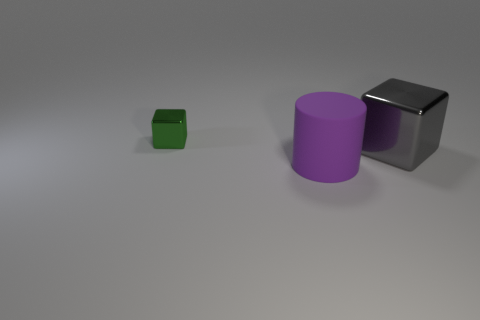There is a metallic object right of the shiny object behind the metal block in front of the tiny shiny cube; how big is it?
Keep it short and to the point. Large. There is a thing that is behind the big purple object and to the left of the big gray object; what is its shape?
Your response must be concise. Cube. Are there an equal number of gray cubes that are right of the purple cylinder and purple rubber things that are on the right side of the gray metallic block?
Ensure brevity in your answer.  No. Is there another cylinder that has the same material as the cylinder?
Give a very brief answer. No. Is the big thing to the left of the gray metallic object made of the same material as the big block?
Your answer should be very brief. No. What is the size of the thing that is to the left of the gray block and behind the purple matte object?
Your answer should be compact. Small. What color is the large cube?
Provide a succinct answer. Gray. What number of small yellow shiny things are there?
Your answer should be compact. 0. How many large shiny things are the same color as the big matte object?
Your answer should be very brief. 0. There is a thing that is behind the big gray shiny thing; does it have the same shape as the big object in front of the big gray metal object?
Your answer should be compact. No. 